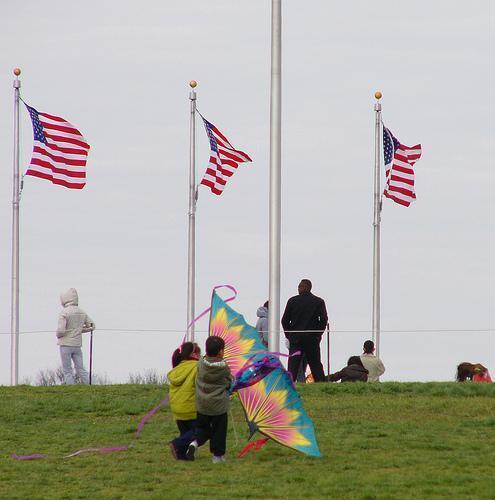How many flags are in the photo?
Give a very brief answer. 3. 